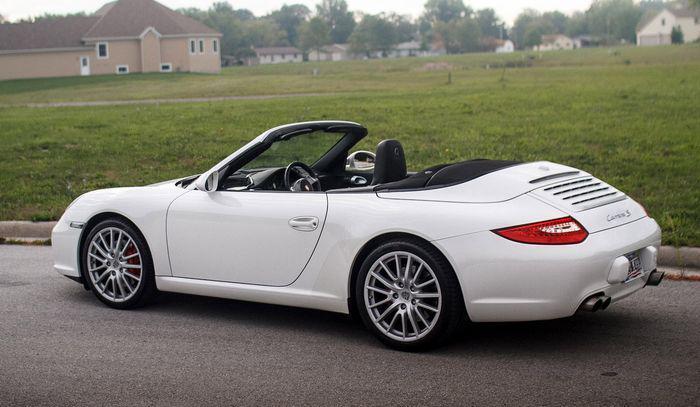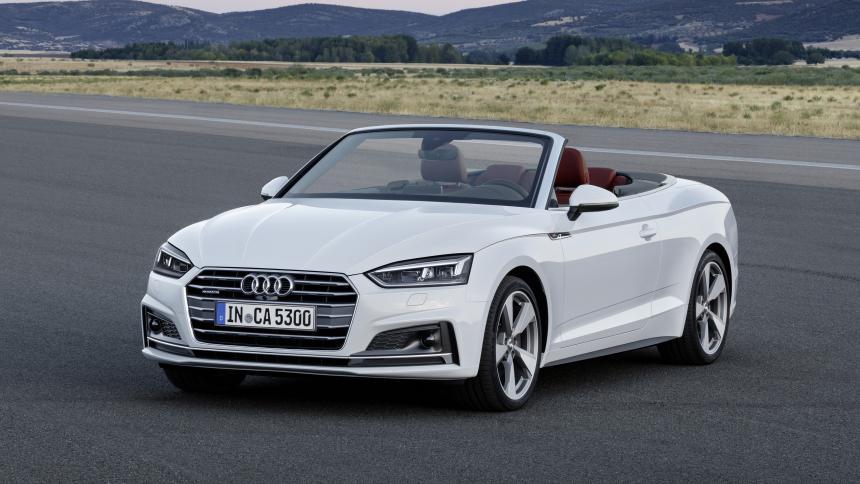The first image is the image on the left, the second image is the image on the right. For the images shown, is this caption "An image shows the back end and tail light of a driverless white convertible with its top down." true? Answer yes or no. Yes. The first image is the image on the left, the second image is the image on the right. Given the left and right images, does the statement "The car on the right is light blue." hold true? Answer yes or no. No. 